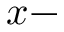Convert formula to latex. <formula><loc_0><loc_0><loc_500><loc_500>x -</formula> 